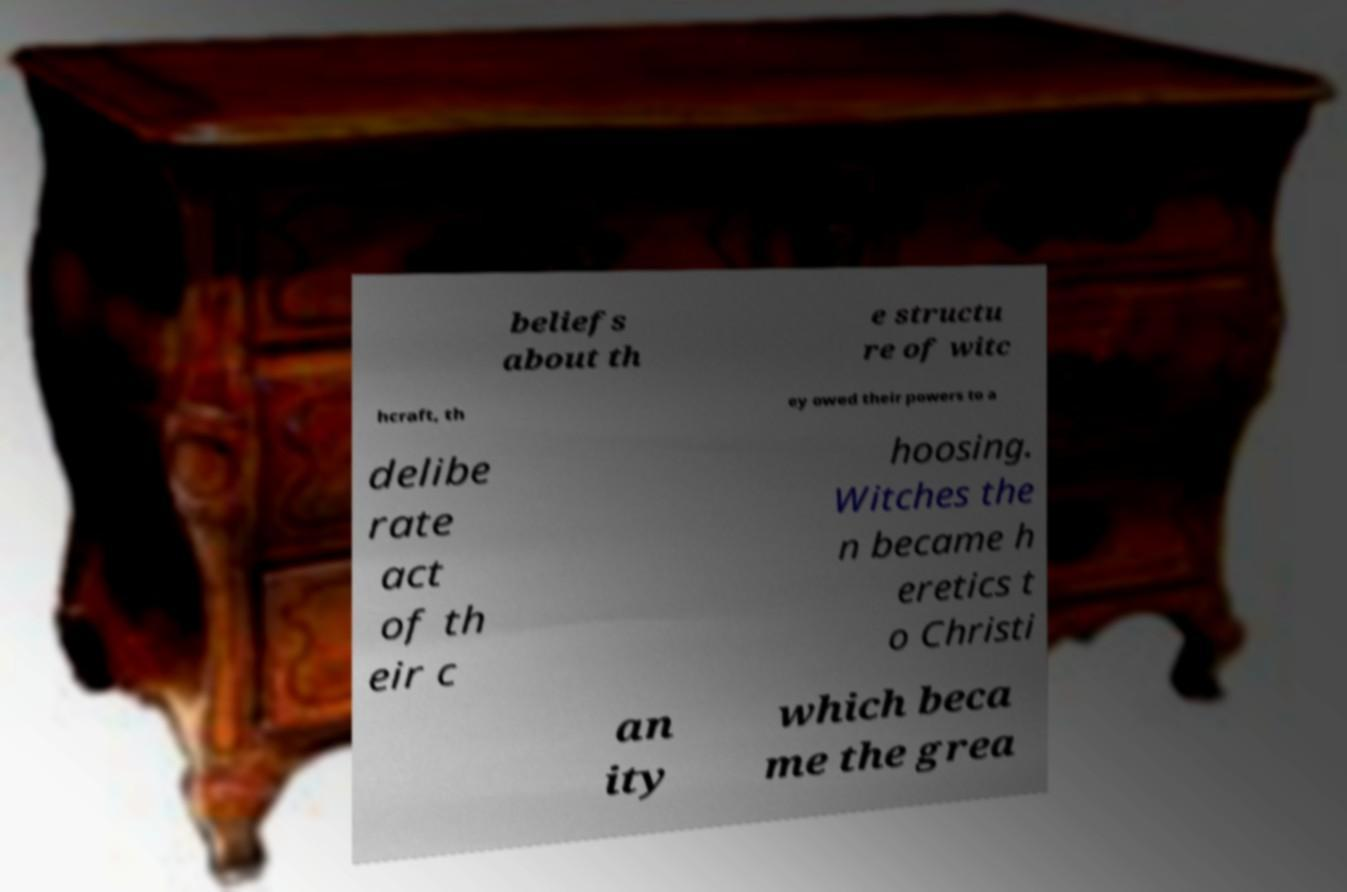I need the written content from this picture converted into text. Can you do that? beliefs about th e structu re of witc hcraft, th ey owed their powers to a delibe rate act of th eir c hoosing. Witches the n became h eretics t o Christi an ity which beca me the grea 